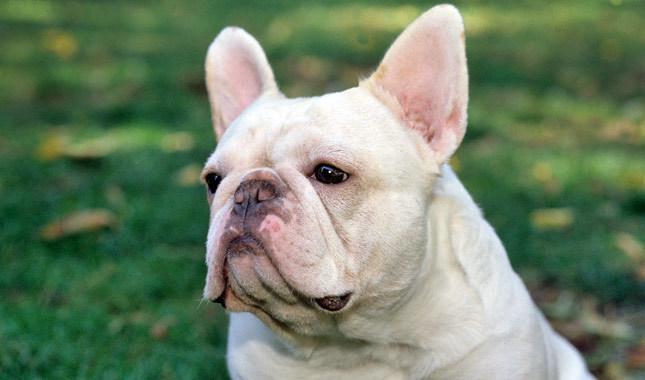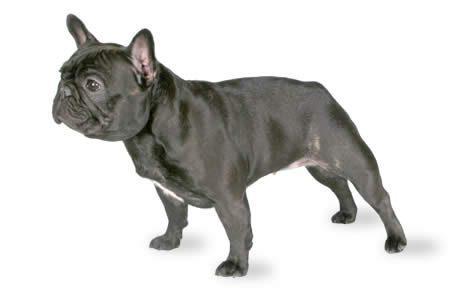The first image is the image on the left, the second image is the image on the right. Evaluate the accuracy of this statement regarding the images: "One of the images does not show the entire body of the dog.". Is it true? Answer yes or no. Yes. 